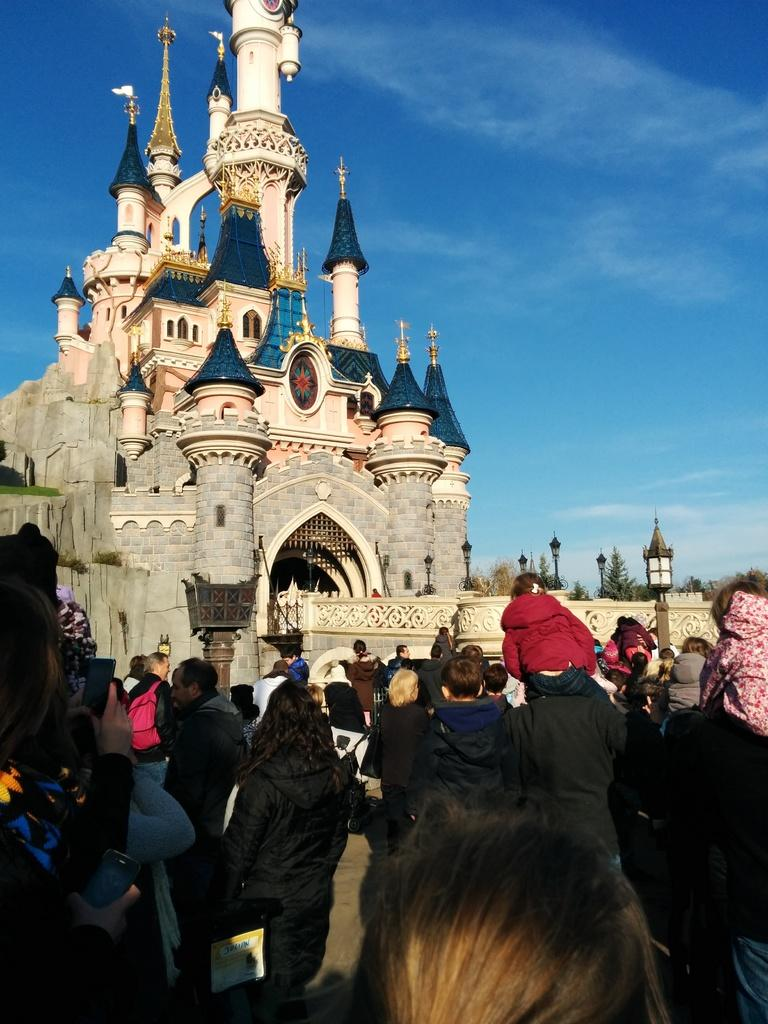How many people are in the image? There is a group of people standing in the image. What can be seen illuminating the scene in the image? There are lights visible in the image. What structures are present in the image? There are poles and a building in the image. What type of vegetation is present in the image? There are trees in the image. What is visible in the background of the image? The sky is visible in the image. What type of hat is the doll wearing in the image? There is no doll present in the image, so it is not possible to answer that question. 